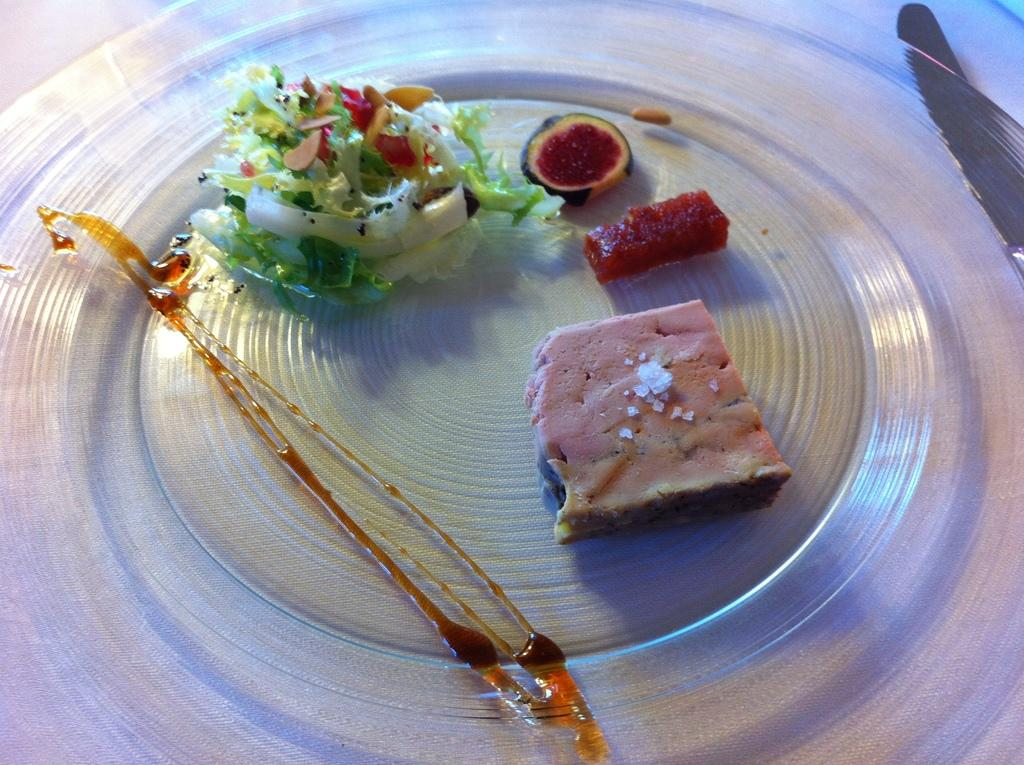What type of objects can be seen in the image? There are food items in the image. How are the food items arranged or displayed? The food items are placed on a glass object. Can you identify any utensils in the image? Yes, there is a knife in the top right-hand corner of the image. What type of roof can be seen on the building in the image? There is no building or roof present in the image; it only features food items, a glass object, and a knife. 